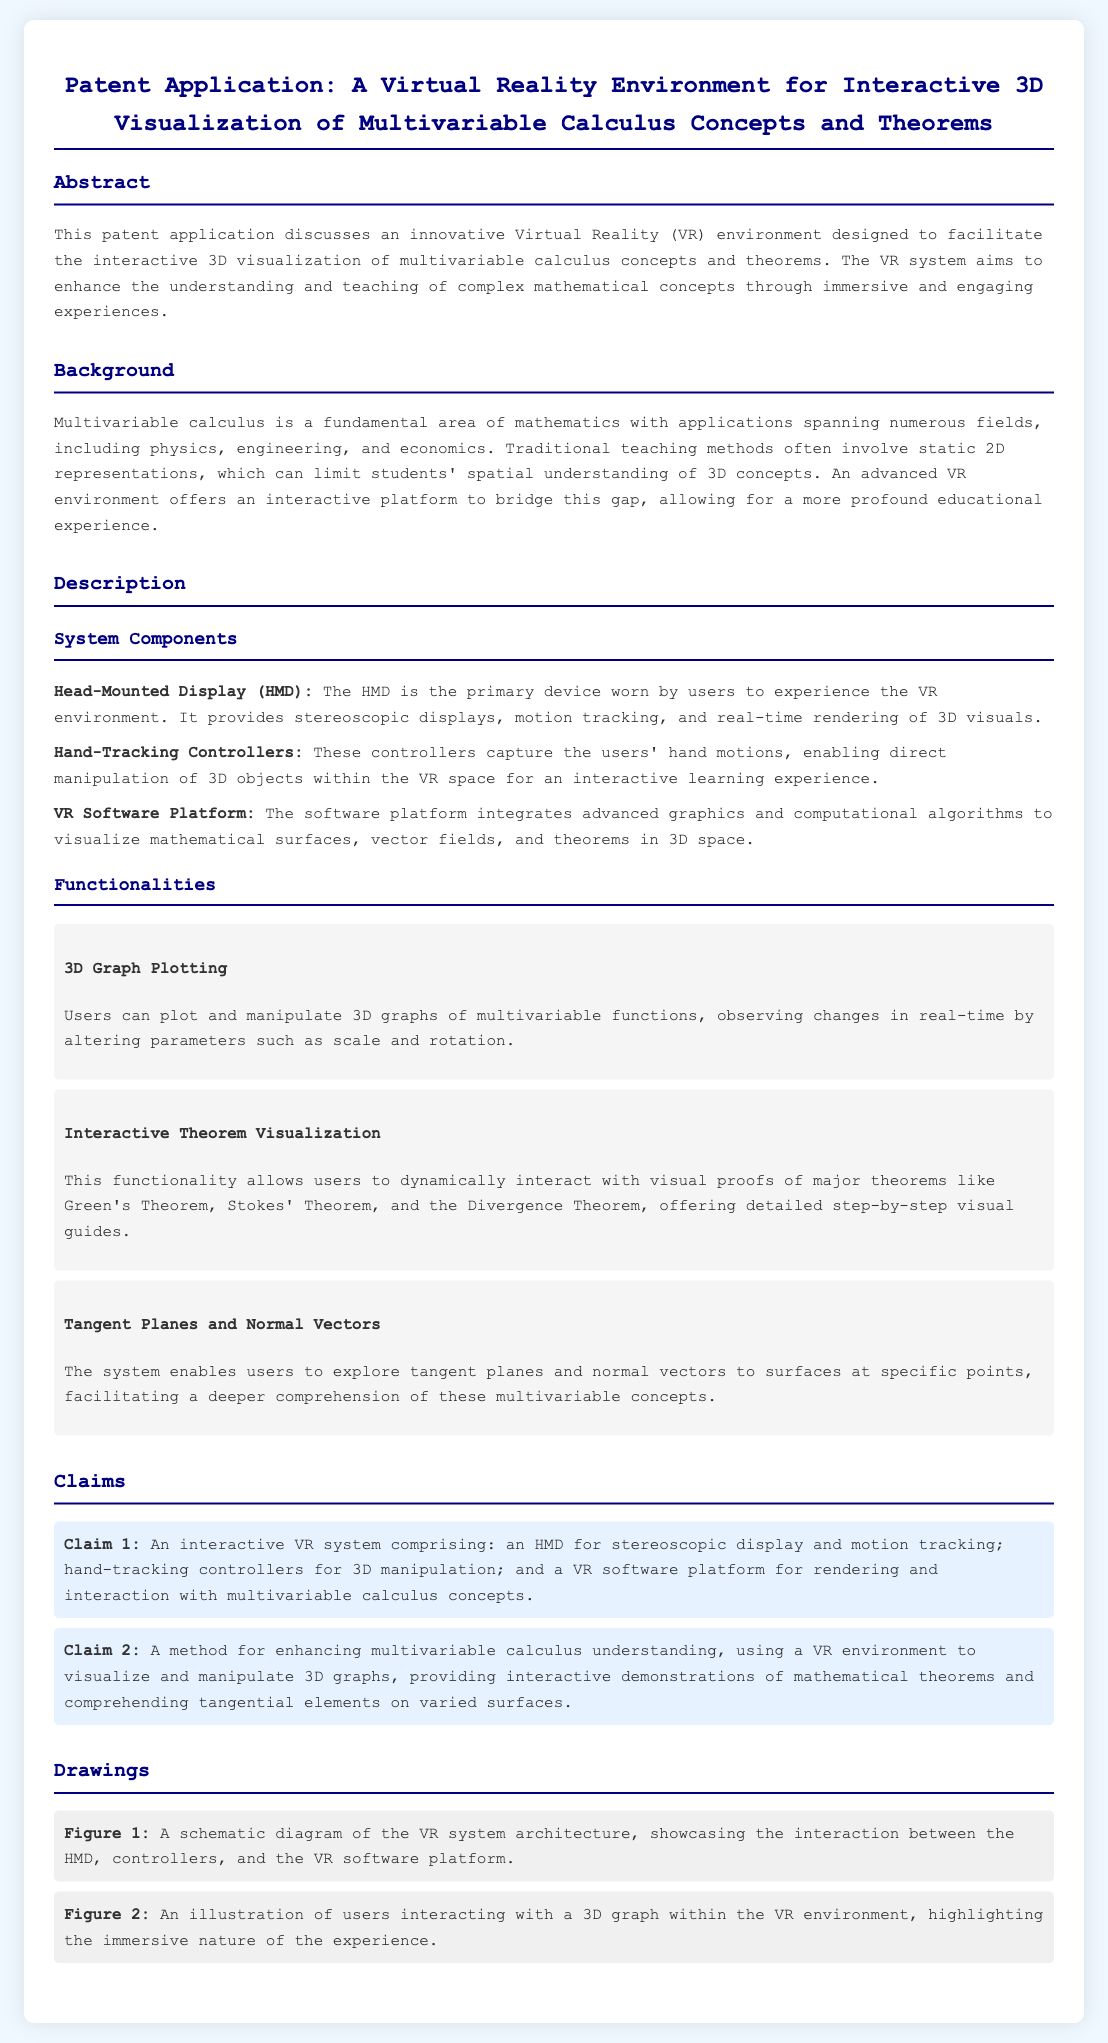What is the title of the patent application? The title of the patent application is the specific phrase mentioned at the beginning of the document.
Answer: A Virtual Reality Environment for Interactive 3D Visualization of Multivariable Calculus Concepts and Theorems What is the primary device used in the VR system? The primary device mentioned in the document for experiencing the VR environment is a specific component.
Answer: Head-Mounted Display (HMD) Which mathematical theorems are mentioned for interactive visualization? The document lists three major theorems as focal points for visualization in the system.
Answer: Green's Theorem, Stokes' Theorem, and the Divergence Theorem How does the VR system enhance understanding of calculus? The document elucidates the method employed to improve comprehension of multivariable calculus concepts, which involves a specific activity.
Answer: Visualize and manipulate 3D graphs What is included in Claim 1 of the patent? Claim 1 outlines specific elements that comprise the interactive VR system, which can be summarized succinctly.
Answer: HMD, hand-tracking controllers, VR software platform What aspect of user interaction does the software platform enable? The software platform's role in user engagement with the system relates to a specific visual process described in the patent.
Answer: Rendering and interaction with multivariable calculus concepts What does the term "tangent planes" refer to in the patent? The document defines the concept of tangent planes within the context of the functionalities provided by the VR environment.
Answer: Multivariable concepts How many figures are included in the drawings section? The document specifies the number of figures present in the drawings section of the patent application.
Answer: 2 